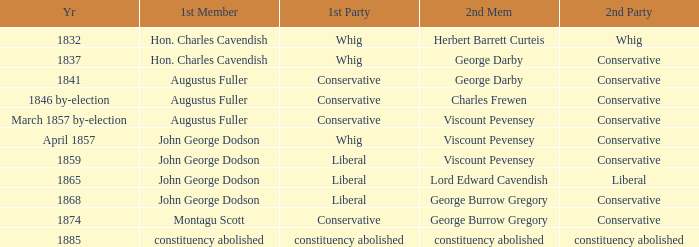In 1837, who was the 2nd member who's 2nd party was conservative. George Darby. 